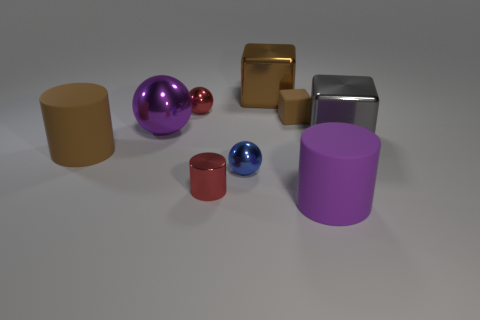Are any blue matte cubes visible?
Keep it short and to the point. No. Is there a gray cylinder made of the same material as the purple cylinder?
Offer a very short reply. No. Is the number of purple objects to the right of the small block greater than the number of purple things behind the red ball?
Your response must be concise. Yes. Do the brown shiny thing and the gray object have the same size?
Your answer should be compact. Yes. There is a rubber cylinder right of the rubber cylinder that is behind the small blue thing; what is its color?
Provide a short and direct response. Purple. The small shiny cylinder is what color?
Offer a terse response. Red. Is there a tiny sphere that has the same color as the small metallic cylinder?
Offer a terse response. Yes. There is a block that is to the left of the tiny brown rubber cube; is it the same color as the small cube?
Offer a very short reply. Yes. How many objects are rubber objects in front of the purple shiny ball or blue matte cylinders?
Make the answer very short. 2. There is a tiny cylinder; are there any brown shiny things in front of it?
Keep it short and to the point. No. 